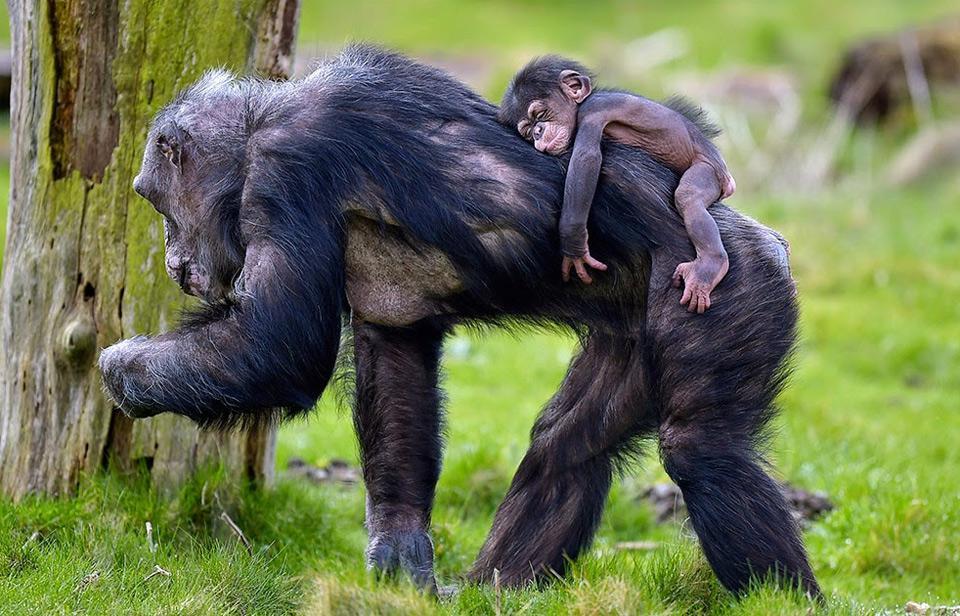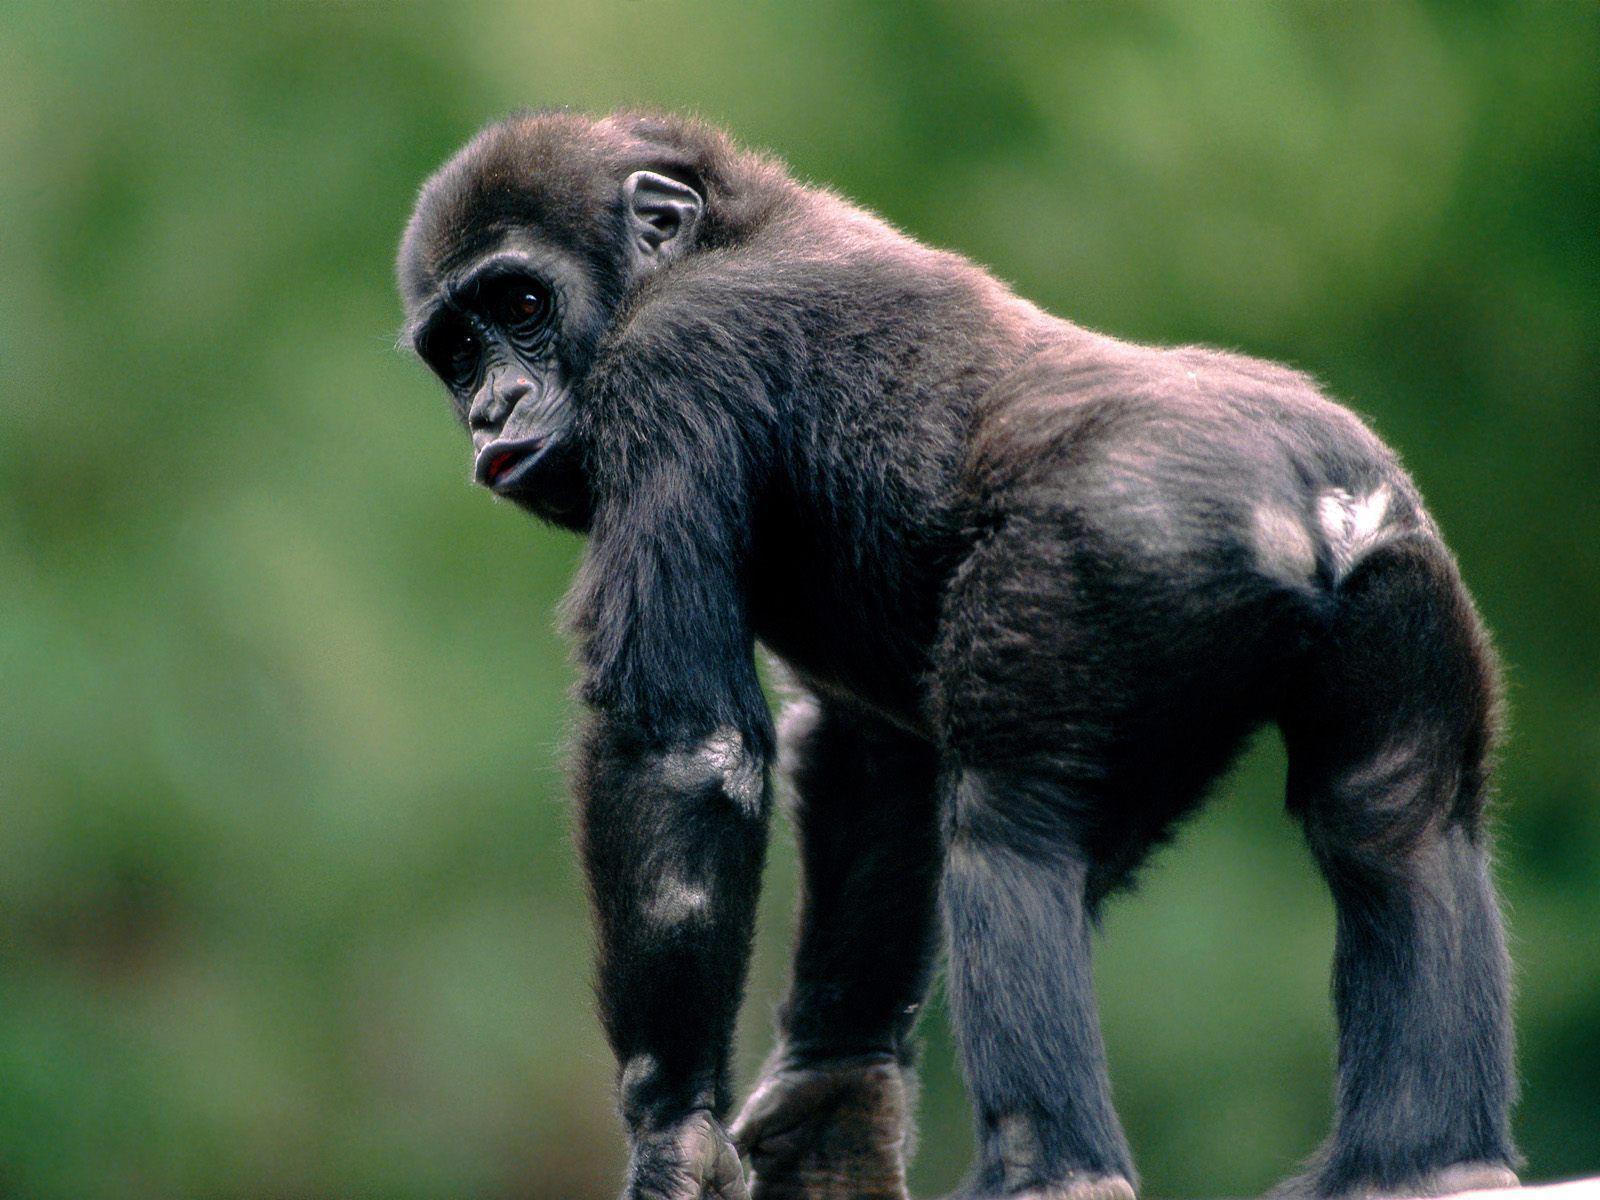The first image is the image on the left, the second image is the image on the right. Assess this claim about the two images: "Just one adult and one young chimp are interacting side-by-side in the left image.". Correct or not? Answer yes or no. No. 